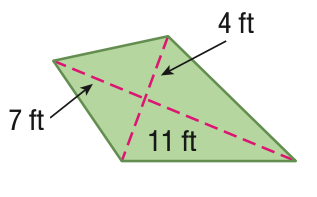Answer the mathemtical geometry problem and directly provide the correct option letter.
Question: Find the area of the kite.
Choices: A: 28 B: 44 C: 72 D: 144 C 